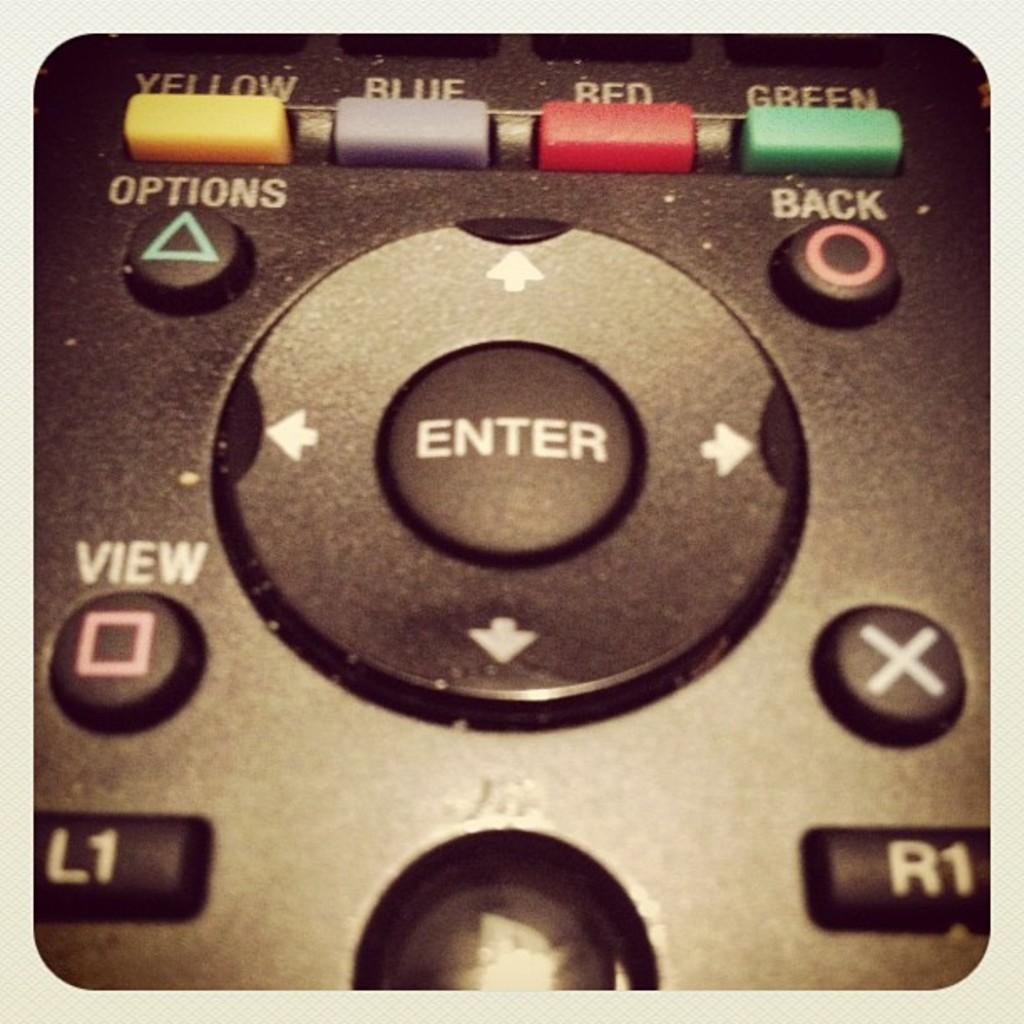What object can be seen in the image? There is a remote in the image. What is written on the remote? The remote has text on it. What colors are the buttons on the remote? The remote has yellow, green, blue, and red color buttons. How many stars can be seen on the remote in the image? There are no stars present on the remote in the image. 